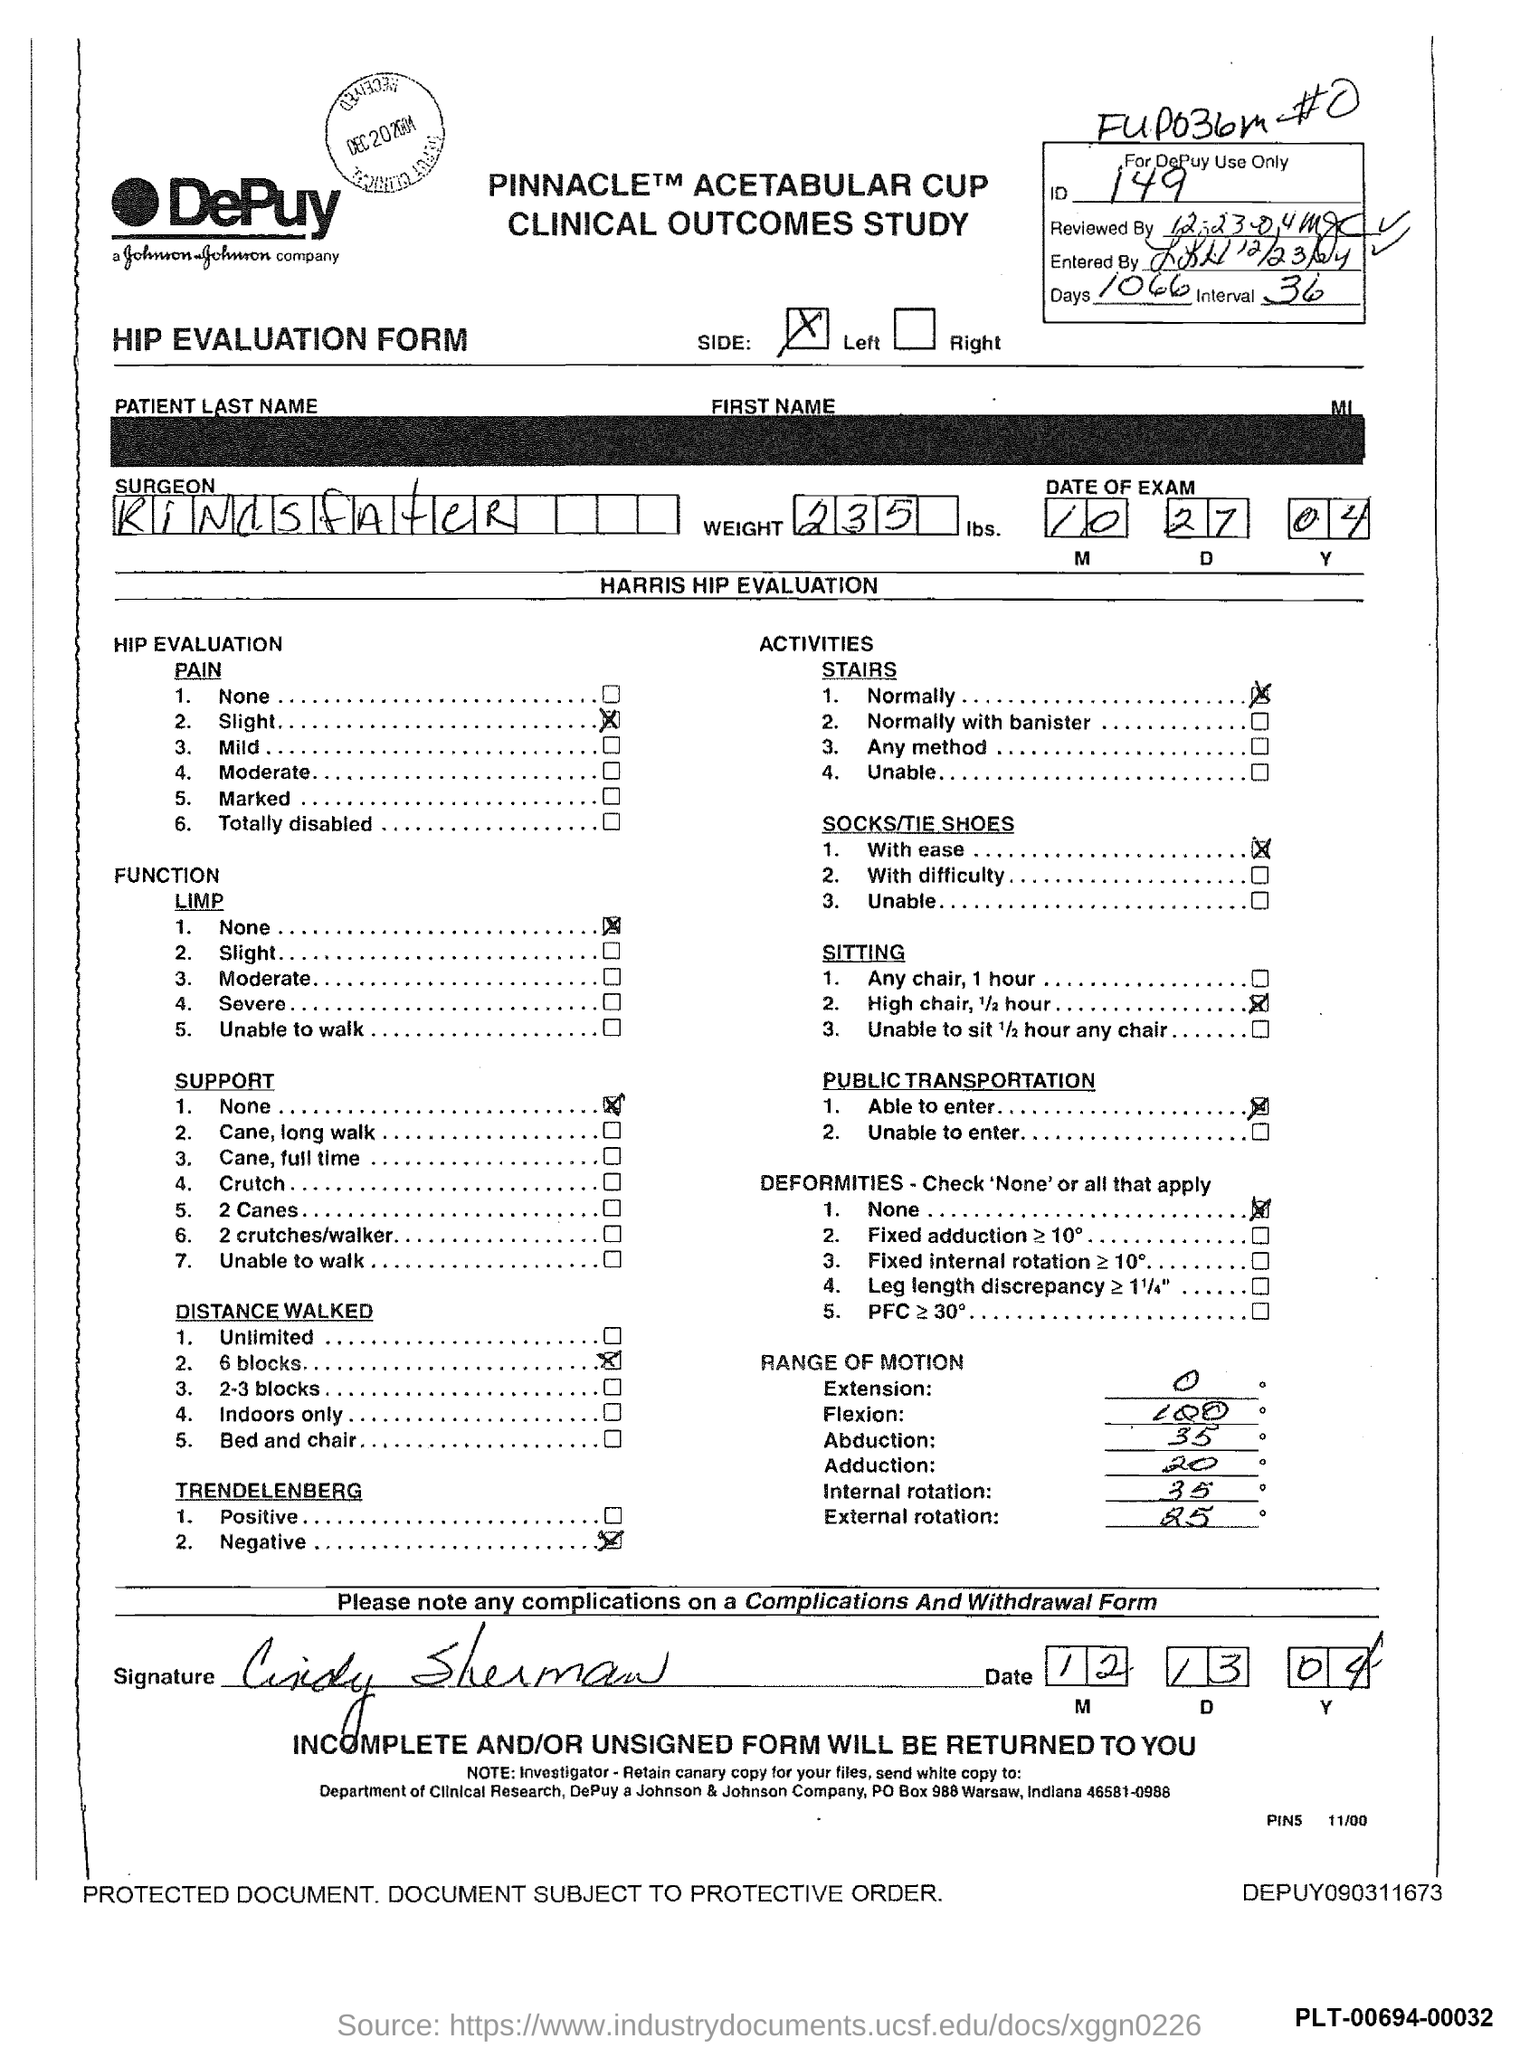What is the id no.?
Offer a very short reply. 149. 